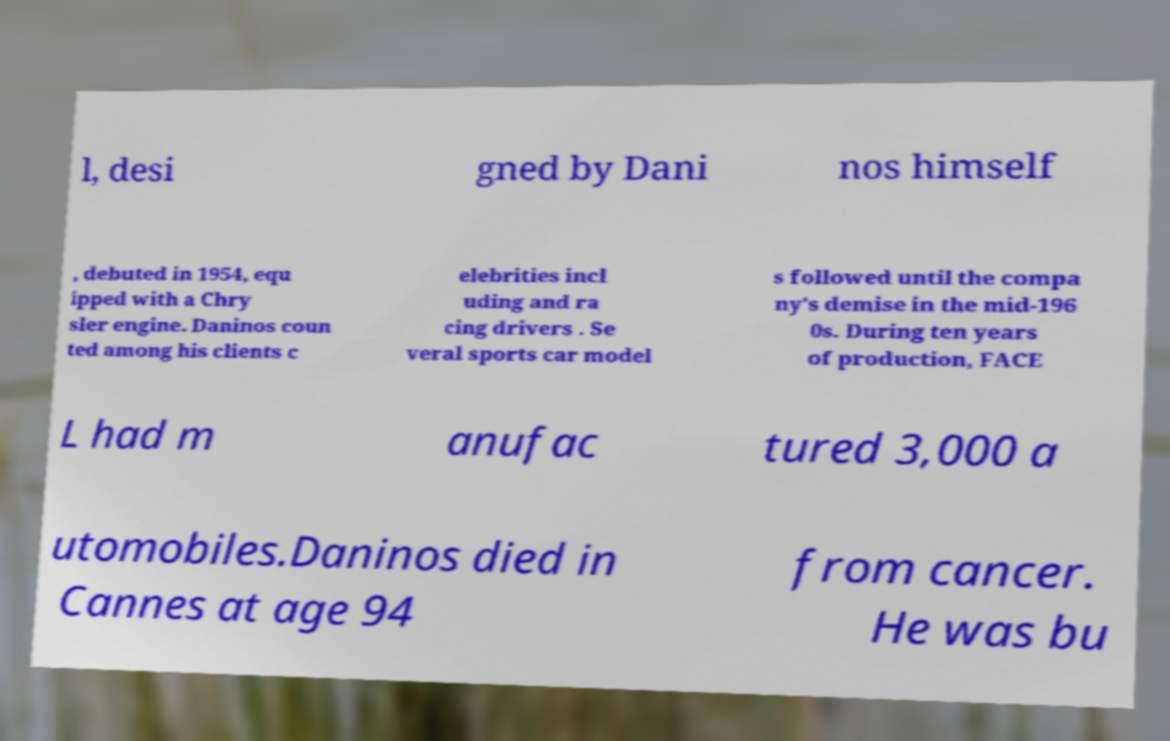What messages or text are displayed in this image? I need them in a readable, typed format. l, desi gned by Dani nos himself , debuted in 1954, equ ipped with a Chry sler engine. Daninos coun ted among his clients c elebrities incl uding and ra cing drivers . Se veral sports car model s followed until the compa ny's demise in the mid-196 0s. During ten years of production, FACE L had m anufac tured 3,000 a utomobiles.Daninos died in Cannes at age 94 from cancer. He was bu 